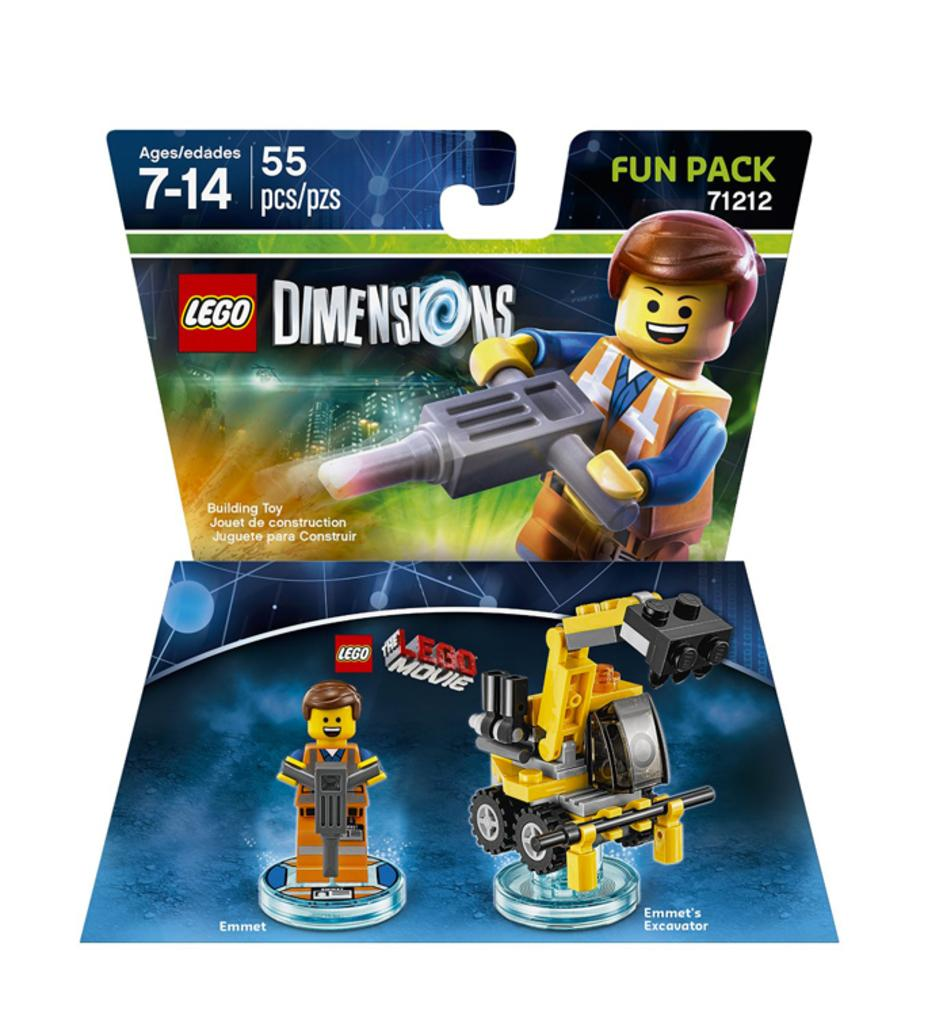What is featured on the posters in the image? The posters contain images of toys. Are there any words on the posters? Yes, the posters have text on them. What else can be seen on the posters besides images and text? The posters have numbers on them. What type of hill can be seen in the background of the image? There is no hill visible in the image; it only features posters with images of toys, text, and numbers. 